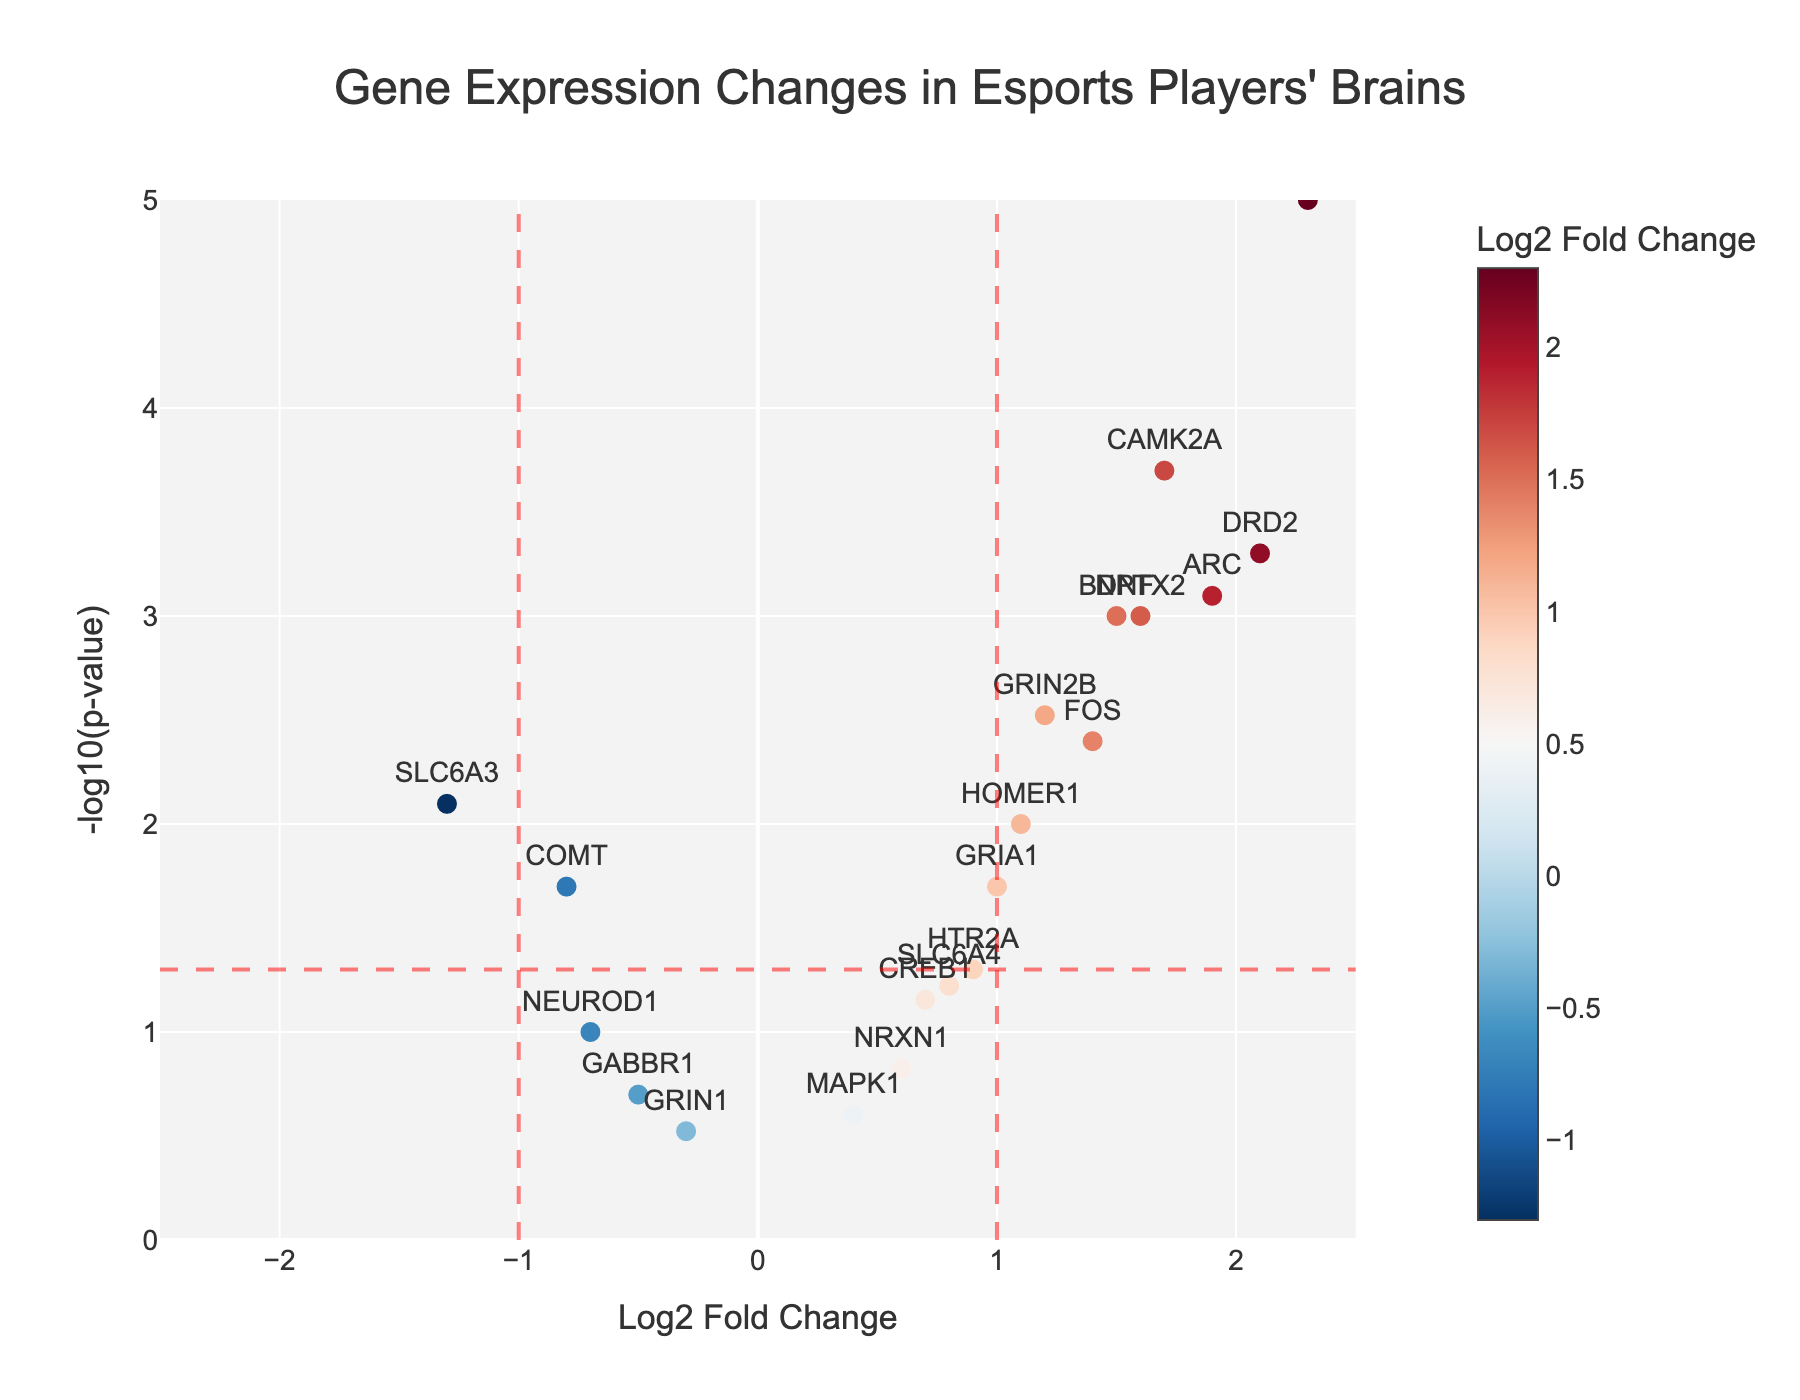What is the title of the figure? The title is at the top of the figure and clearly states what the data represents.
Answer: Gene Expression Changes in Esports Players' Brains How many genes show significant changes at p-value < 0.05? Visual inspection shows the number of points above the horizontal threshold line at -log10(p)=1.3, signifying p-value < 0.05. Count the points above this line.
Answer: 14 Which gene has the highest log2 fold change? Look at the x-axis values and identify the gene with the highest positive log2 fold change.
Answer: NPAS4 What is the log2 fold change of the gene DRD2? Locate DRD2 on the plot and read its position on the x-axis.
Answer: 2.1 Which gene has the lowest p-value? The lowest p-value corresponds to the highest y-axis value. Find the gene that is highest on the plot.
Answer: NPAS4 Which gene has a log2 fold change close to zero and is non-significant in terms of p-value? Identify points near the x-axis (log2 fold change = 0) and below the threshold line at y = 1.3.
Answer: GABBR1 How many genes are upregulated with log2 fold change > 1? Count the points with x-axis values greater than 1 and above the threshold line.
Answer: 6 Which gene has a log2 fold change of approximately 1.7 and a highly significant p-value? Locate the gene near x-axis 1.7 with a high y-axis value (log10(p-value)).
Answer: CAMK2A Between the genes BDNF and COMT, which one exhibits a more significant change? Compare their y-axis positions (-log10(p-value)). The gene higher up has a higher significance.
Answer: BDNF What is the p-value of gene ARC converted to the -log10 scale? Use the formula -log10(p-value) for the given p-value of ARC.
Answer: 3.10 